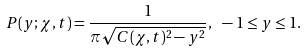Convert formula to latex. <formula><loc_0><loc_0><loc_500><loc_500>P ( y ; \chi , t ) = \frac { 1 } { \pi \sqrt { C ( \chi , t ) ^ { 2 } - y ^ { 2 } } } , \text { } - 1 \leq y \leq 1 .</formula> 